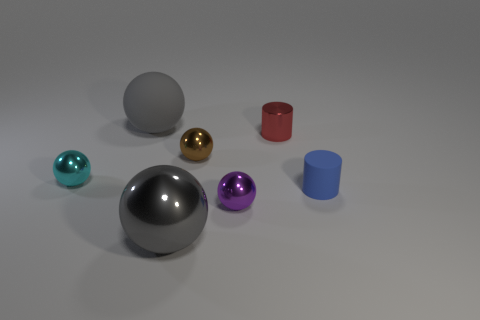Subtract all brown spheres. How many spheres are left? 4 Subtract all purple balls. How many balls are left? 4 Subtract all blue spheres. Subtract all green cylinders. How many spheres are left? 5 Add 2 red matte objects. How many objects exist? 9 Subtract all spheres. How many objects are left? 2 Add 3 big brown rubber cylinders. How many big brown rubber cylinders exist? 3 Subtract 1 purple spheres. How many objects are left? 6 Subtract all large gray metallic balls. Subtract all red things. How many objects are left? 5 Add 4 tiny blue cylinders. How many tiny blue cylinders are left? 5 